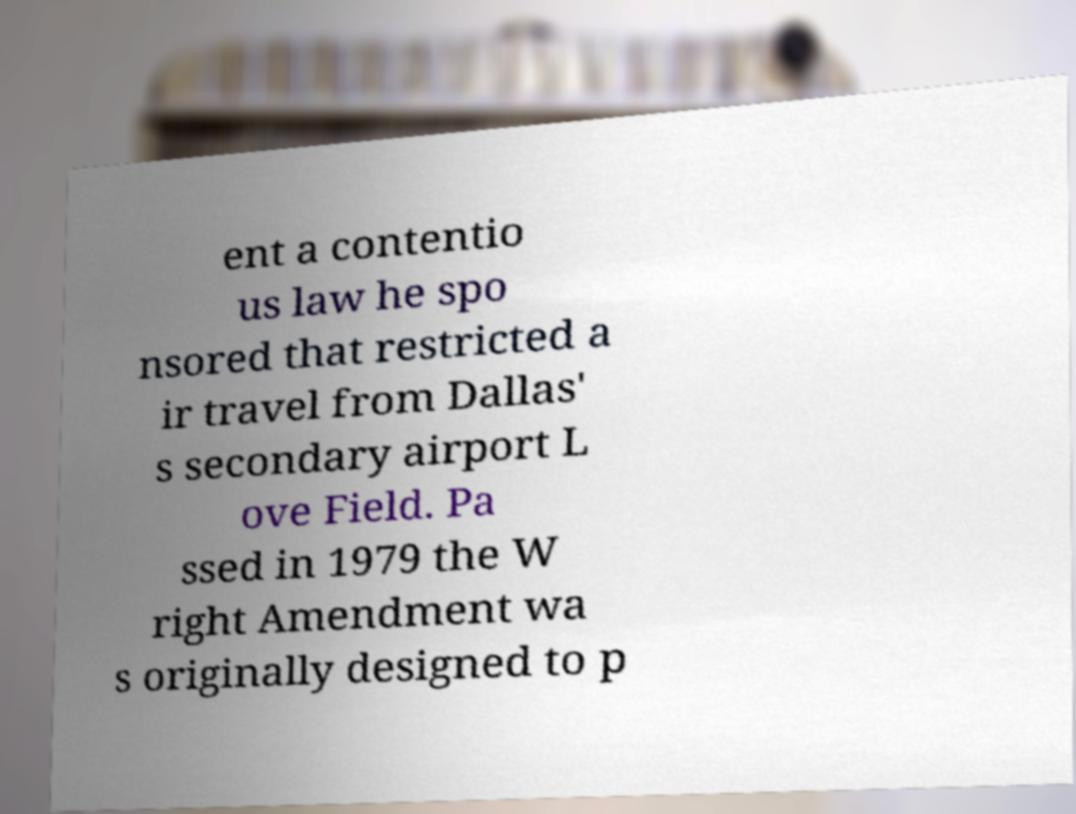For documentation purposes, I need the text within this image transcribed. Could you provide that? ent a contentio us law he spo nsored that restricted a ir travel from Dallas' s secondary airport L ove Field. Pa ssed in 1979 the W right Amendment wa s originally designed to p 